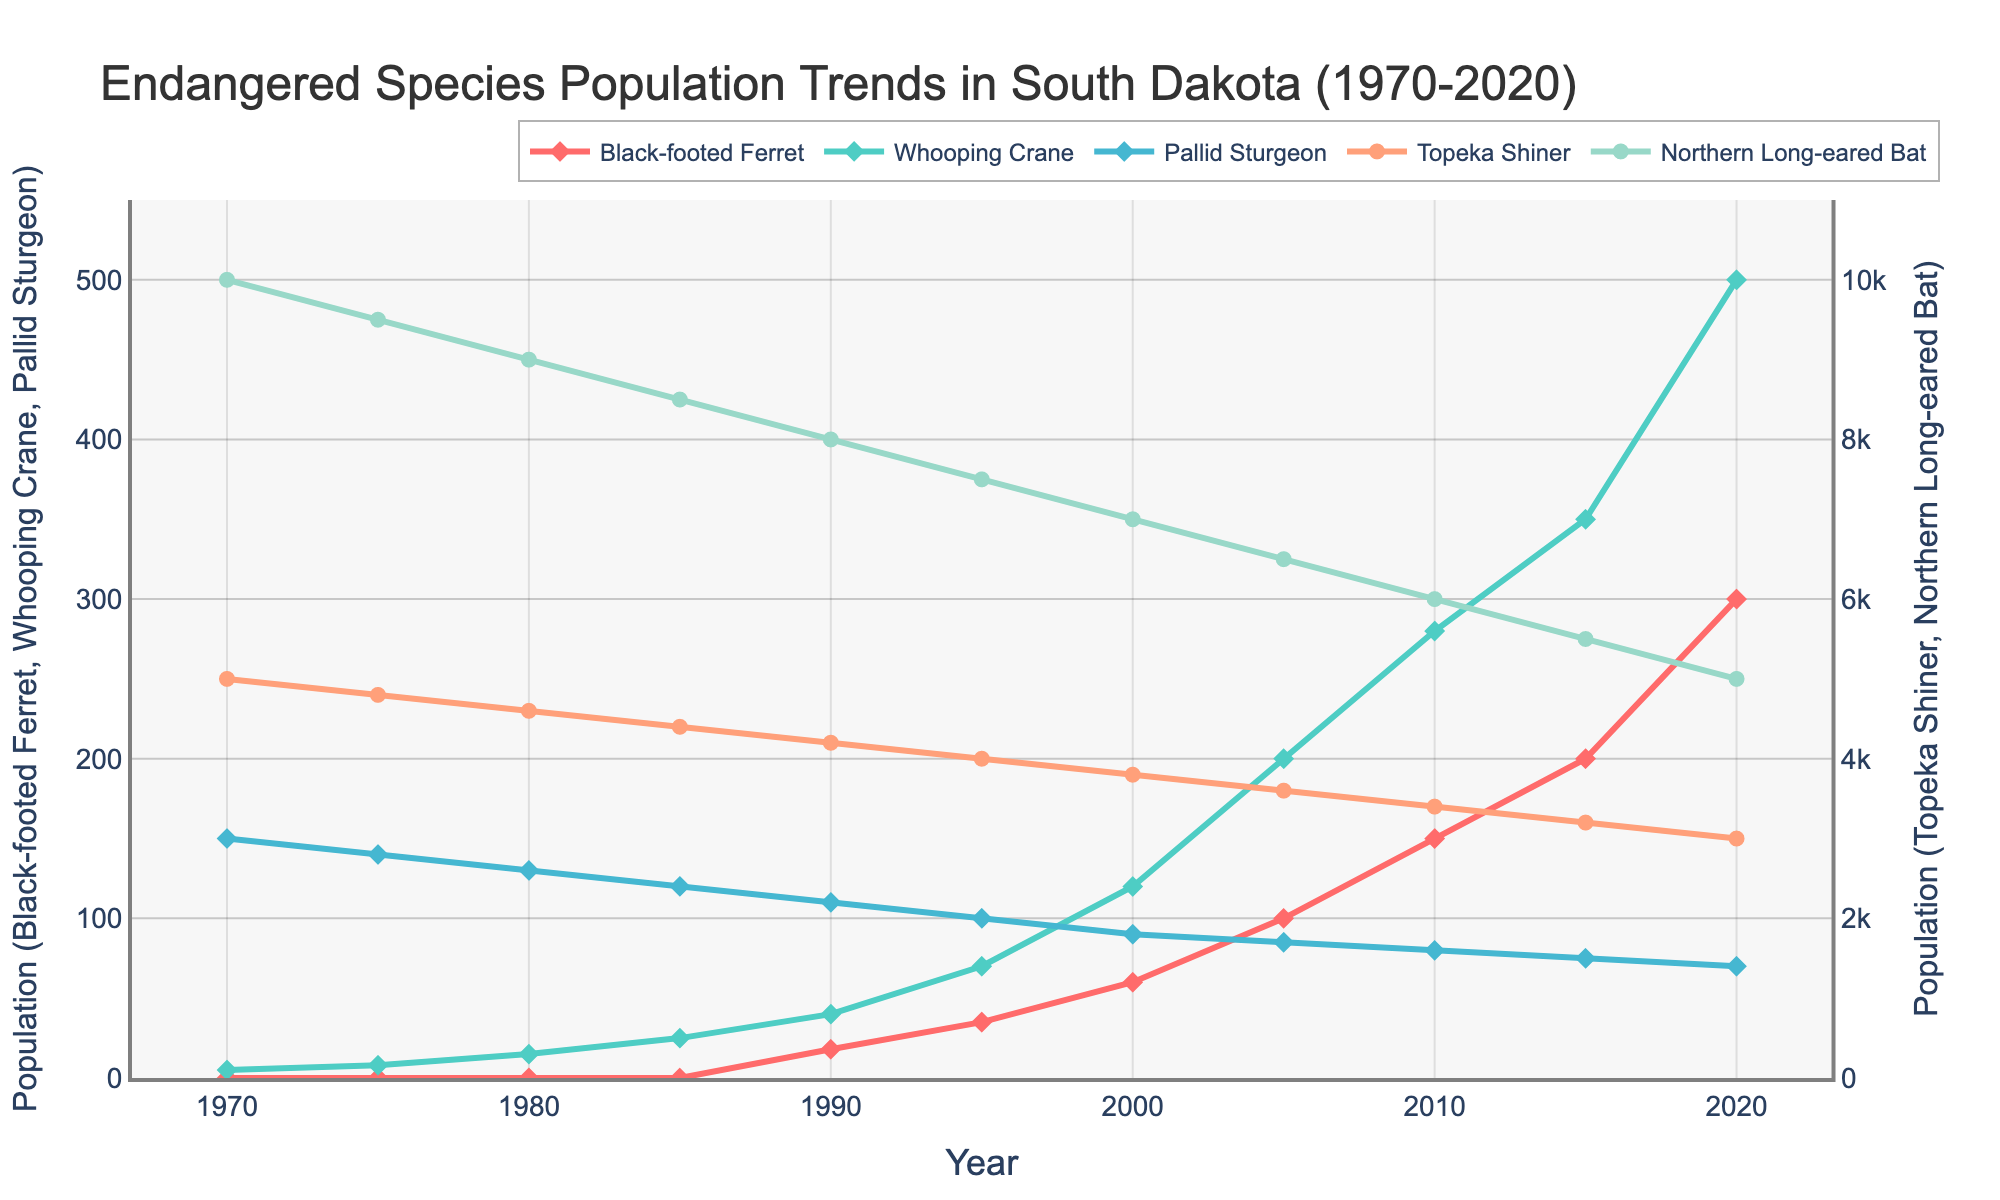What is the most significant population increase for any species between two consecutive periods? Compare the population change between each consecutive period for all species. The most significant increase is for the Whooping Crane from 2000 to 2005, which is an increase of 80 (200 - 120).
Answer: 80 (Whooping Crane, 2000-2005) Which species had the lowest population in 1970? From the start of the chart in 1970, the Black-footed Ferret had a population of 0, which is the lowest among all species listed.
Answer: Black-footed Ferret Which species shows a continuous increase in population over the 50-year period? Observe the trend lines for each species. The Black-footed Ferret shows a continuous increase without any decrease over the 50-year period.
Answer: Black-footed Ferret Between 2000 and 2020, which species's population did not experience any decrease? Check the trend lines between 2000 and 2020. Both the Black-footed Ferret and Whooping Crane populations continuously increased during this period.
Answer: Black-footed Ferret, Whooping Crane Compare the population of the Pallid Sturgeon and Northern Long-eared Bat in 1990. Which is greater? Look at the points for 1990 on the graph for the two species. The Pallid Sturgeon population is 110, and the Northern Long-eared Bat population is 8000. The bat population is greater.
Answer: Northern Long-eared Bat By how much did the Topeka Shiner population decline from 1970 to 2020? Find the values for the Topeka Shiner in 1970 (5000) and 2020 (3000). The decline is 5000 - 3000 = 2000.
Answer: 2000 Which species has the highest population by 2020? Look at the data points for 2020. The Northern Long-eared Bat has the highest population with 5000 individuals.
Answer: Northern Long-eared Bat How much did the Black-footed Ferret population increase between 1990 and 2010? Find the population numbers for 1990 (18) and 2010 (150). Calculate the increase: 150 - 18 = 132.
Answer: 132 What is the average population of Whooping Crane between 1995 and 2020? Find the values for 1995, 2000, 2005, 2010, 2015, and 2020: 70, 120, 200, 280, 350, 500. Sum them (70+120+200+280+350+500=1520) and divide by 6: 1520/6 = 253.33.
Answer: 253.33 Which two species had equal populations in 2010? Check the 2010 data points and compare values. The Pallid Sturgeon and Topeka Shiner both had populations of 80.
Answer: Pallid Sturgeon, Topeka Shiner 